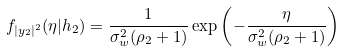Convert formula to latex. <formula><loc_0><loc_0><loc_500><loc_500>f _ { | y _ { 2 } | ^ { 2 } } ( \eta | h _ { 2 } ) = \frac { 1 } { \sigma _ { w } ^ { 2 } ( \rho _ { 2 } + 1 ) } \exp \left ( - \frac { \eta } { \sigma _ { w } ^ { 2 } ( \rho _ { 2 } + 1 ) } \right )</formula> 